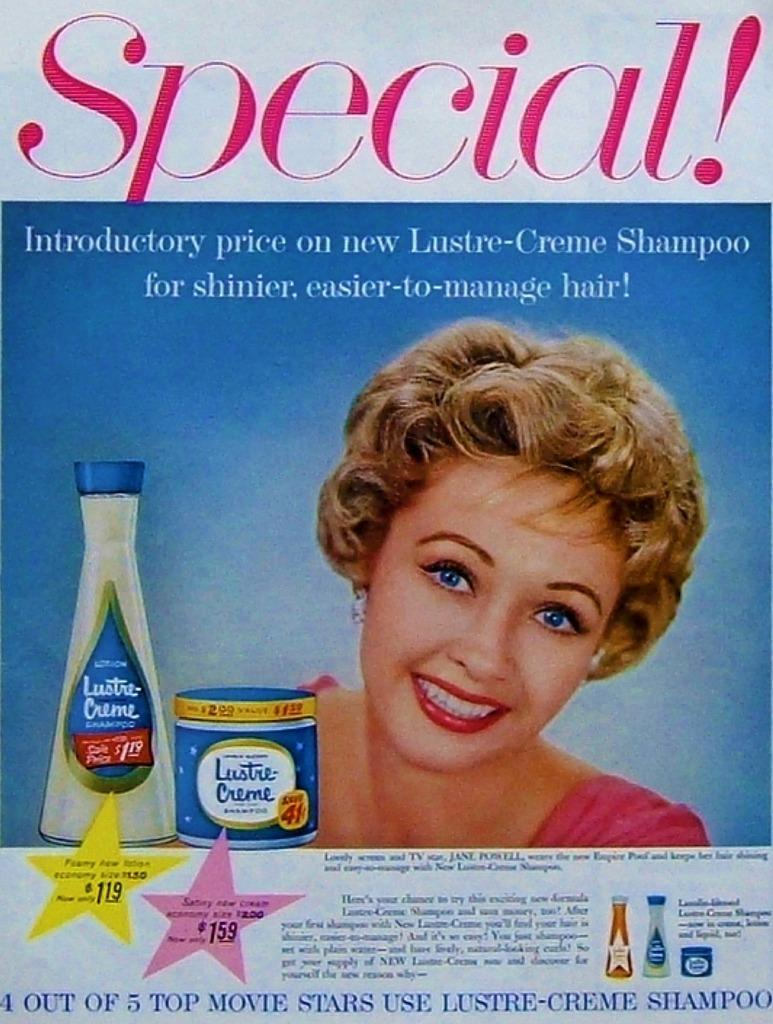<image>
Relay a brief, clear account of the picture shown. An old ad that has a lady on it smiling and says Special that has two bottles of Lustre Cream on it. 